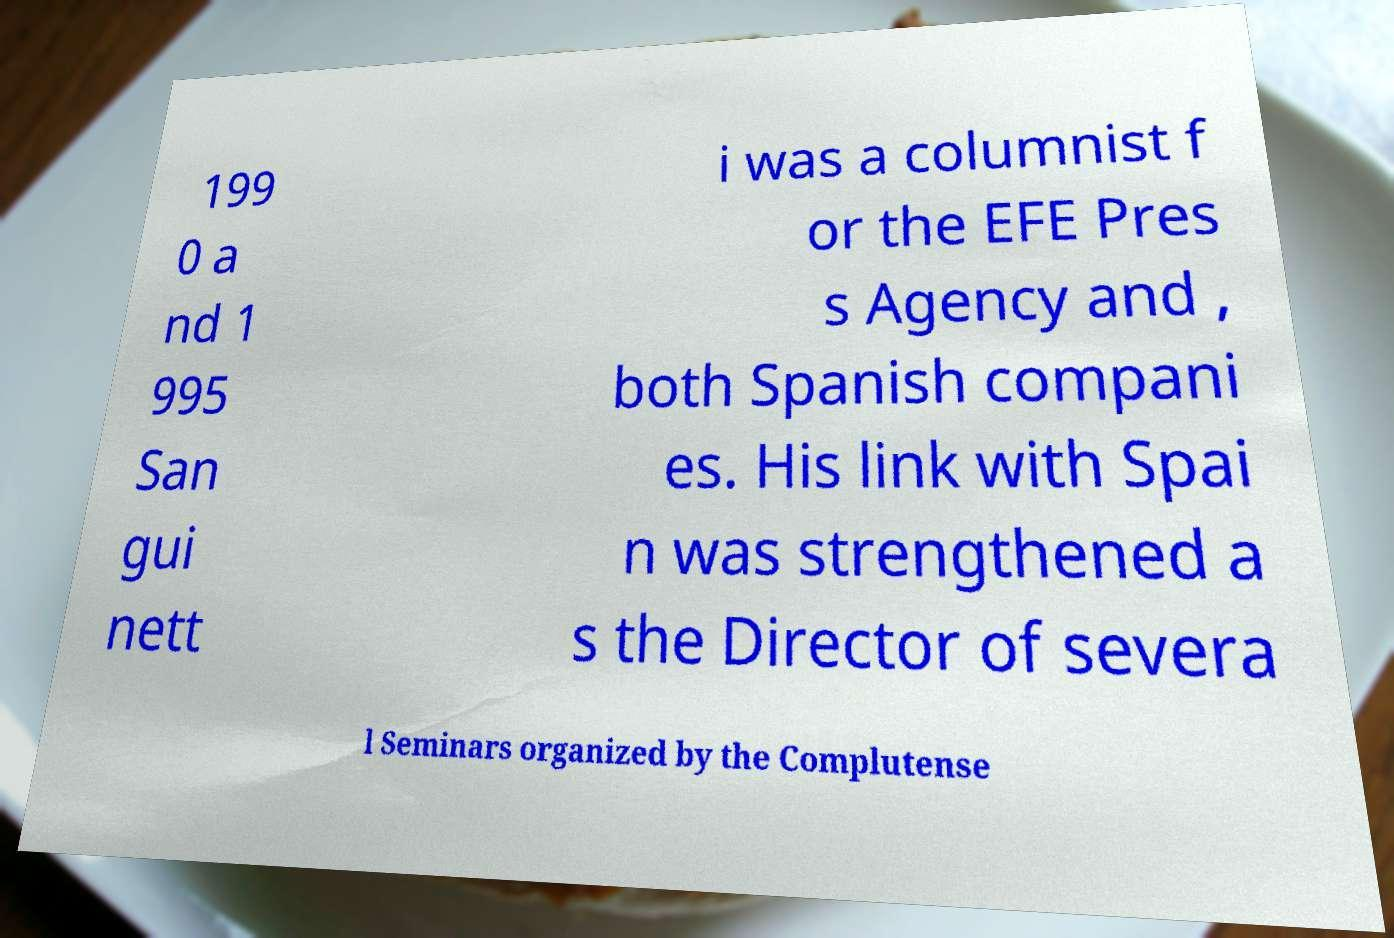I need the written content from this picture converted into text. Can you do that? 199 0 a nd 1 995 San gui nett i was a columnist f or the EFE Pres s Agency and , both Spanish compani es. His link with Spai n was strengthened a s the Director of severa l Seminars organized by the Complutense 